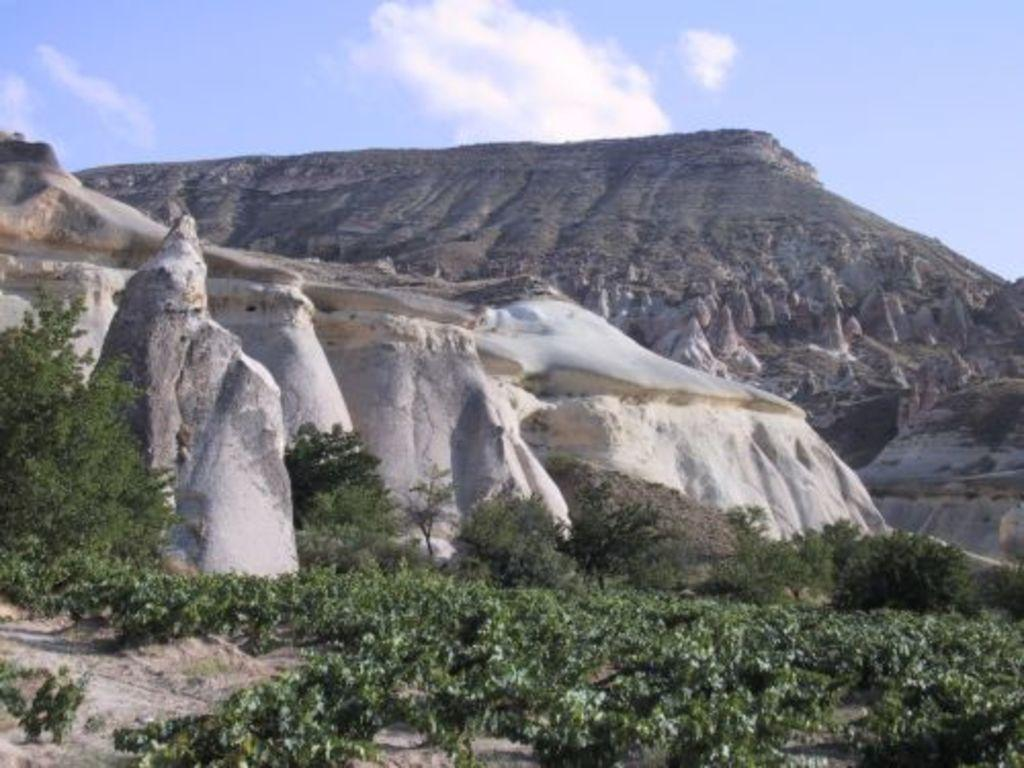What type of vegetation can be seen in the image? There are plants and trees in the image. What type of landscape feature is present in the image? There are hills in the image. What can be seen in the background of the image? The sky is visible in the background of the image. How many tickets are visible in the image? There are no tickets present in the image. What type of boys can be seen playing in the image? There are no boys present in the image. 